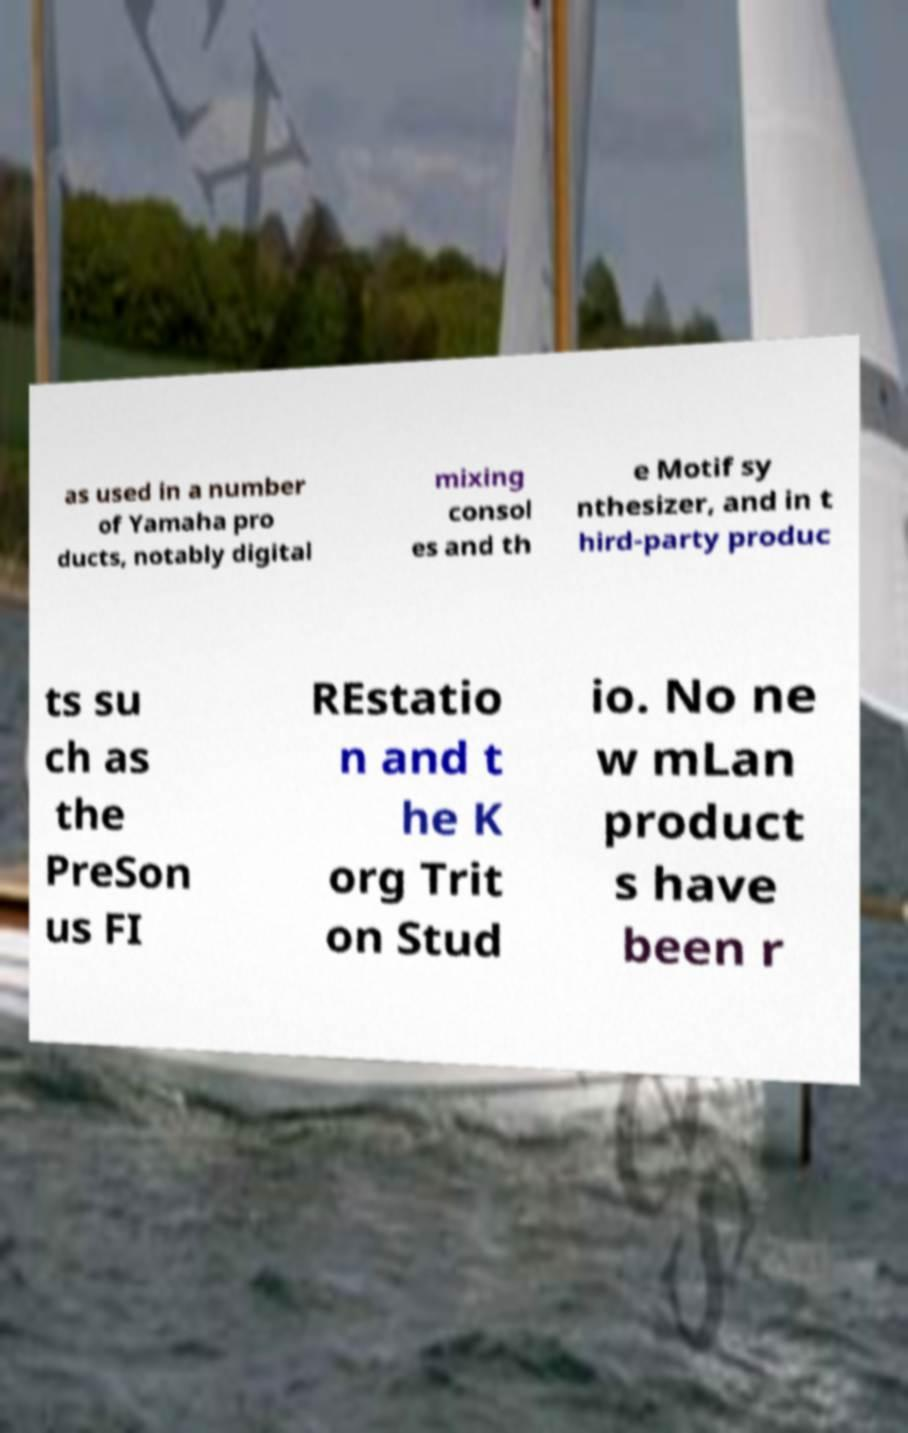There's text embedded in this image that I need extracted. Can you transcribe it verbatim? as used in a number of Yamaha pro ducts, notably digital mixing consol es and th e Motif sy nthesizer, and in t hird-party produc ts su ch as the PreSon us FI REstatio n and t he K org Trit on Stud io. No ne w mLan product s have been r 